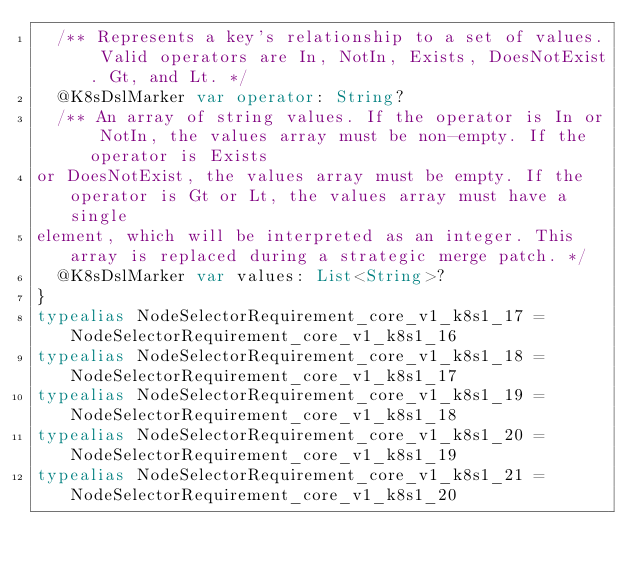Convert code to text. <code><loc_0><loc_0><loc_500><loc_500><_Kotlin_>  /** Represents a key's relationship to a set of values. Valid operators are In, NotIn, Exists, DoesNotExist. Gt, and Lt. */
  @K8sDslMarker var operator: String?
  /** An array of string values. If the operator is In or NotIn, the values array must be non-empty. If the operator is Exists
or DoesNotExist, the values array must be empty. If the operator is Gt or Lt, the values array must have a single
element, which will be interpreted as an integer. This array is replaced during a strategic merge patch. */
  @K8sDslMarker var values: List<String>?
}      
typealias NodeSelectorRequirement_core_v1_k8s1_17 = NodeSelectorRequirement_core_v1_k8s1_16       
typealias NodeSelectorRequirement_core_v1_k8s1_18 = NodeSelectorRequirement_core_v1_k8s1_17       
typealias NodeSelectorRequirement_core_v1_k8s1_19 = NodeSelectorRequirement_core_v1_k8s1_18       
typealias NodeSelectorRequirement_core_v1_k8s1_20 = NodeSelectorRequirement_core_v1_k8s1_19       
typealias NodeSelectorRequirement_core_v1_k8s1_21 = NodeSelectorRequirement_core_v1_k8s1_20 </code> 